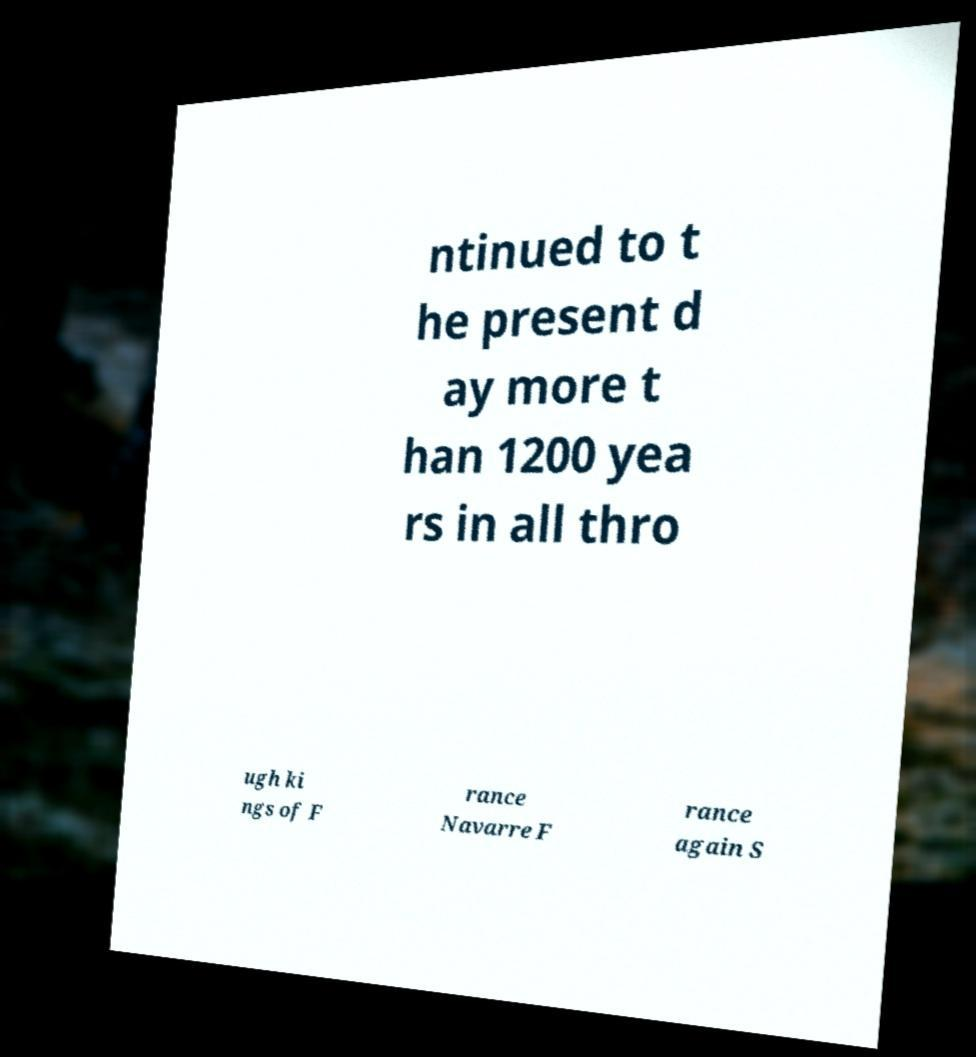Can you read and provide the text displayed in the image?This photo seems to have some interesting text. Can you extract and type it out for me? ntinued to t he present d ay more t han 1200 yea rs in all thro ugh ki ngs of F rance Navarre F rance again S 